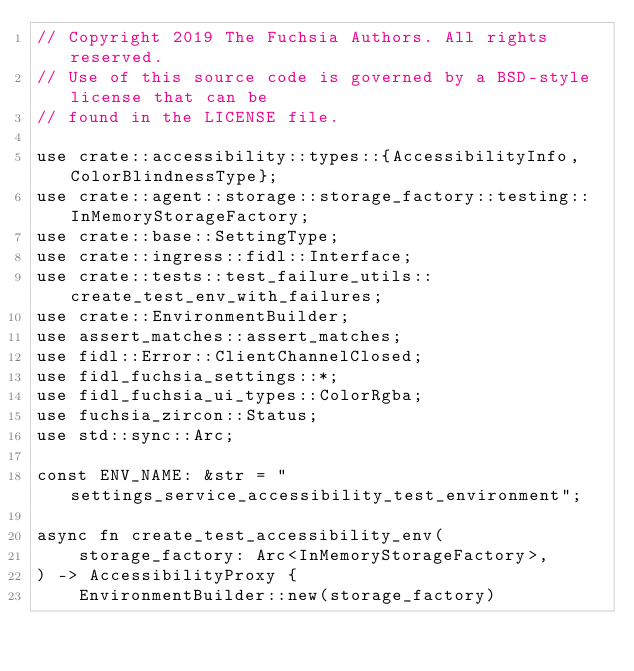Convert code to text. <code><loc_0><loc_0><loc_500><loc_500><_Rust_>// Copyright 2019 The Fuchsia Authors. All rights reserved.
// Use of this source code is governed by a BSD-style license that can be
// found in the LICENSE file.

use crate::accessibility::types::{AccessibilityInfo, ColorBlindnessType};
use crate::agent::storage::storage_factory::testing::InMemoryStorageFactory;
use crate::base::SettingType;
use crate::ingress::fidl::Interface;
use crate::tests::test_failure_utils::create_test_env_with_failures;
use crate::EnvironmentBuilder;
use assert_matches::assert_matches;
use fidl::Error::ClientChannelClosed;
use fidl_fuchsia_settings::*;
use fidl_fuchsia_ui_types::ColorRgba;
use fuchsia_zircon::Status;
use std::sync::Arc;

const ENV_NAME: &str = "settings_service_accessibility_test_environment";

async fn create_test_accessibility_env(
    storage_factory: Arc<InMemoryStorageFactory>,
) -> AccessibilityProxy {
    EnvironmentBuilder::new(storage_factory)</code> 